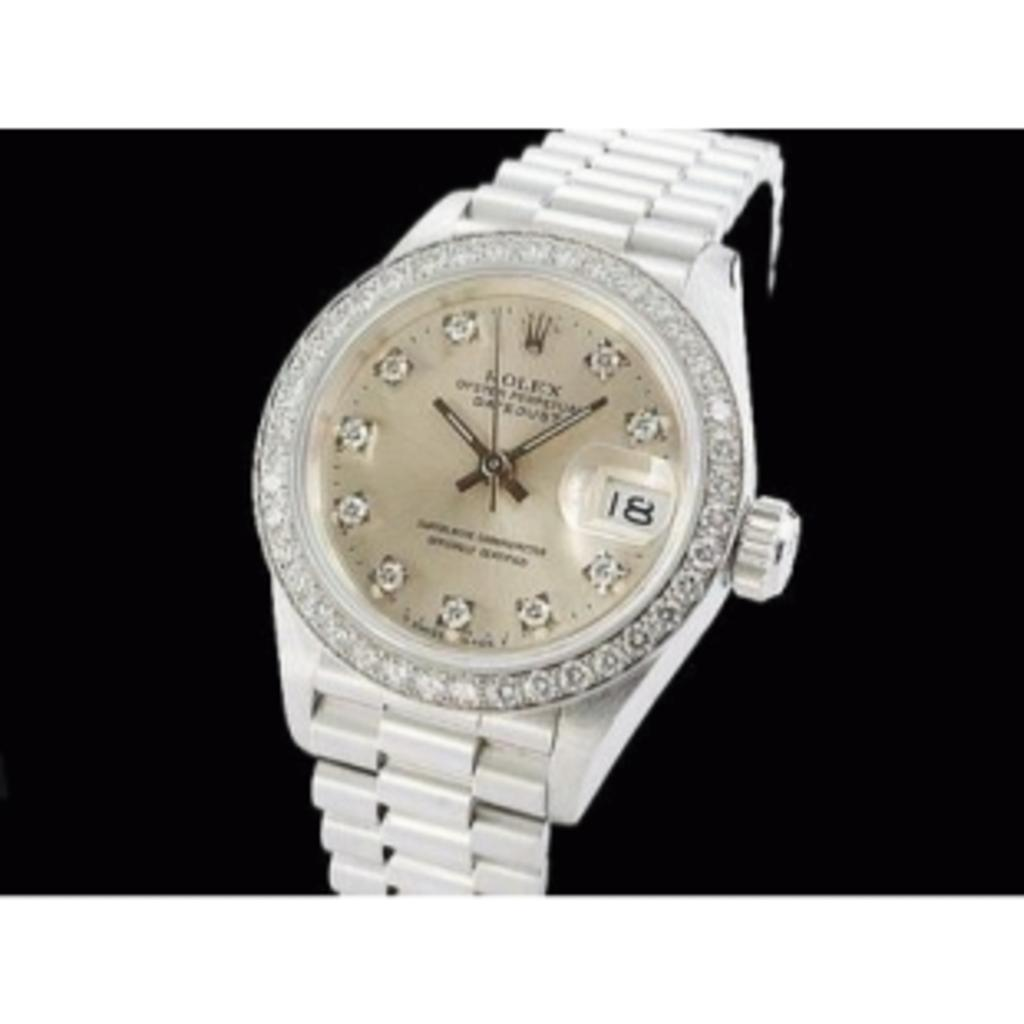<image>
Give a short and clear explanation of the subsequent image. A silver Rolex watch with a diamond bezel. 